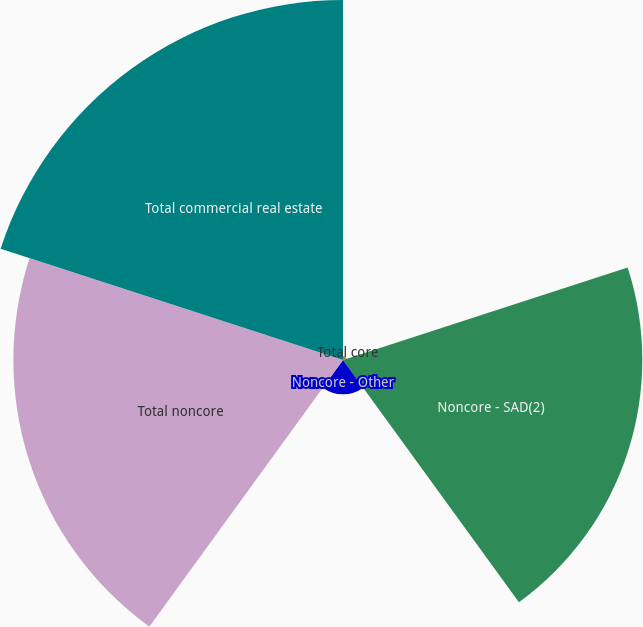Convert chart. <chart><loc_0><loc_0><loc_500><loc_500><pie_chart><fcel>Total core<fcel>Noncore - SAD(2)<fcel>Noncore - Other<fcel>Total noncore<fcel>Total commercial real estate<nl><fcel>0.38%<fcel>29.14%<fcel>3.34%<fcel>32.09%<fcel>35.05%<nl></chart> 